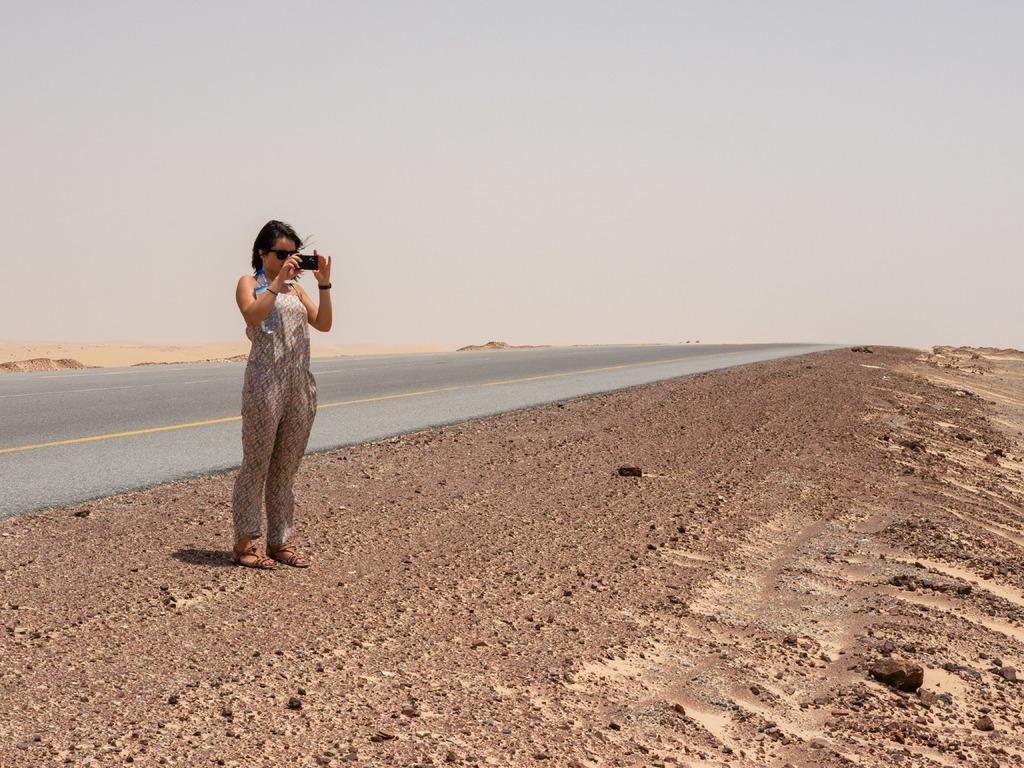Could you give a brief overview of what you see in this image? In this image I can see the person standing and holding the mobile. In the background I can see the sky in white color. 